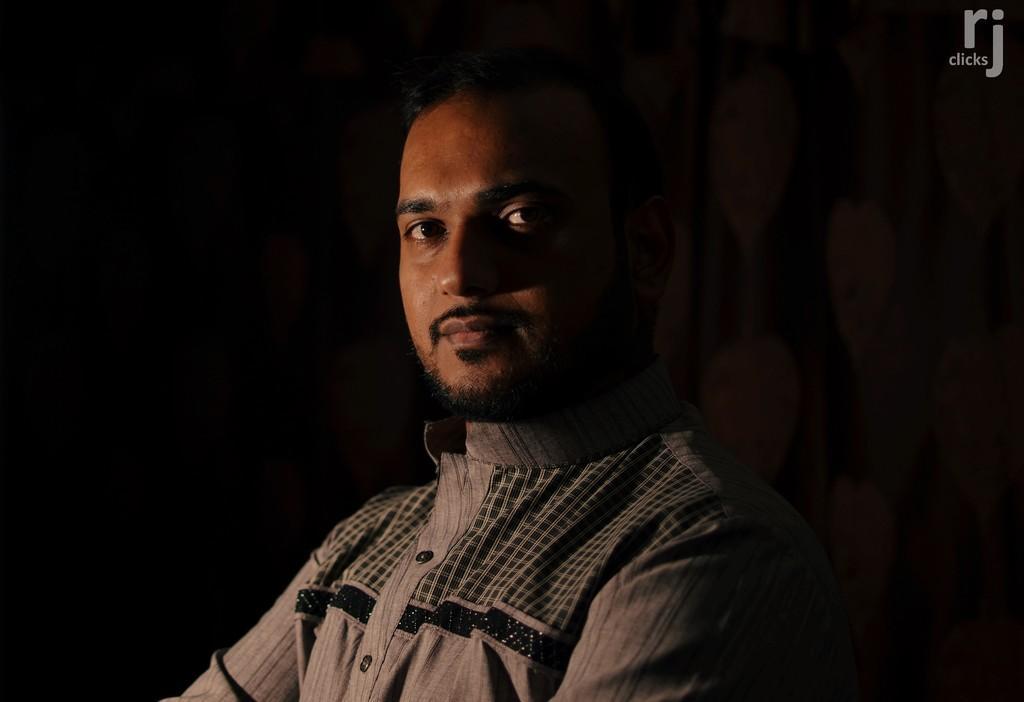Describe this image in one or two sentences. In this image we can see a person wearing shirt is here. The background of the image is dark. Here we can see the watermark at the top right side of the image. 